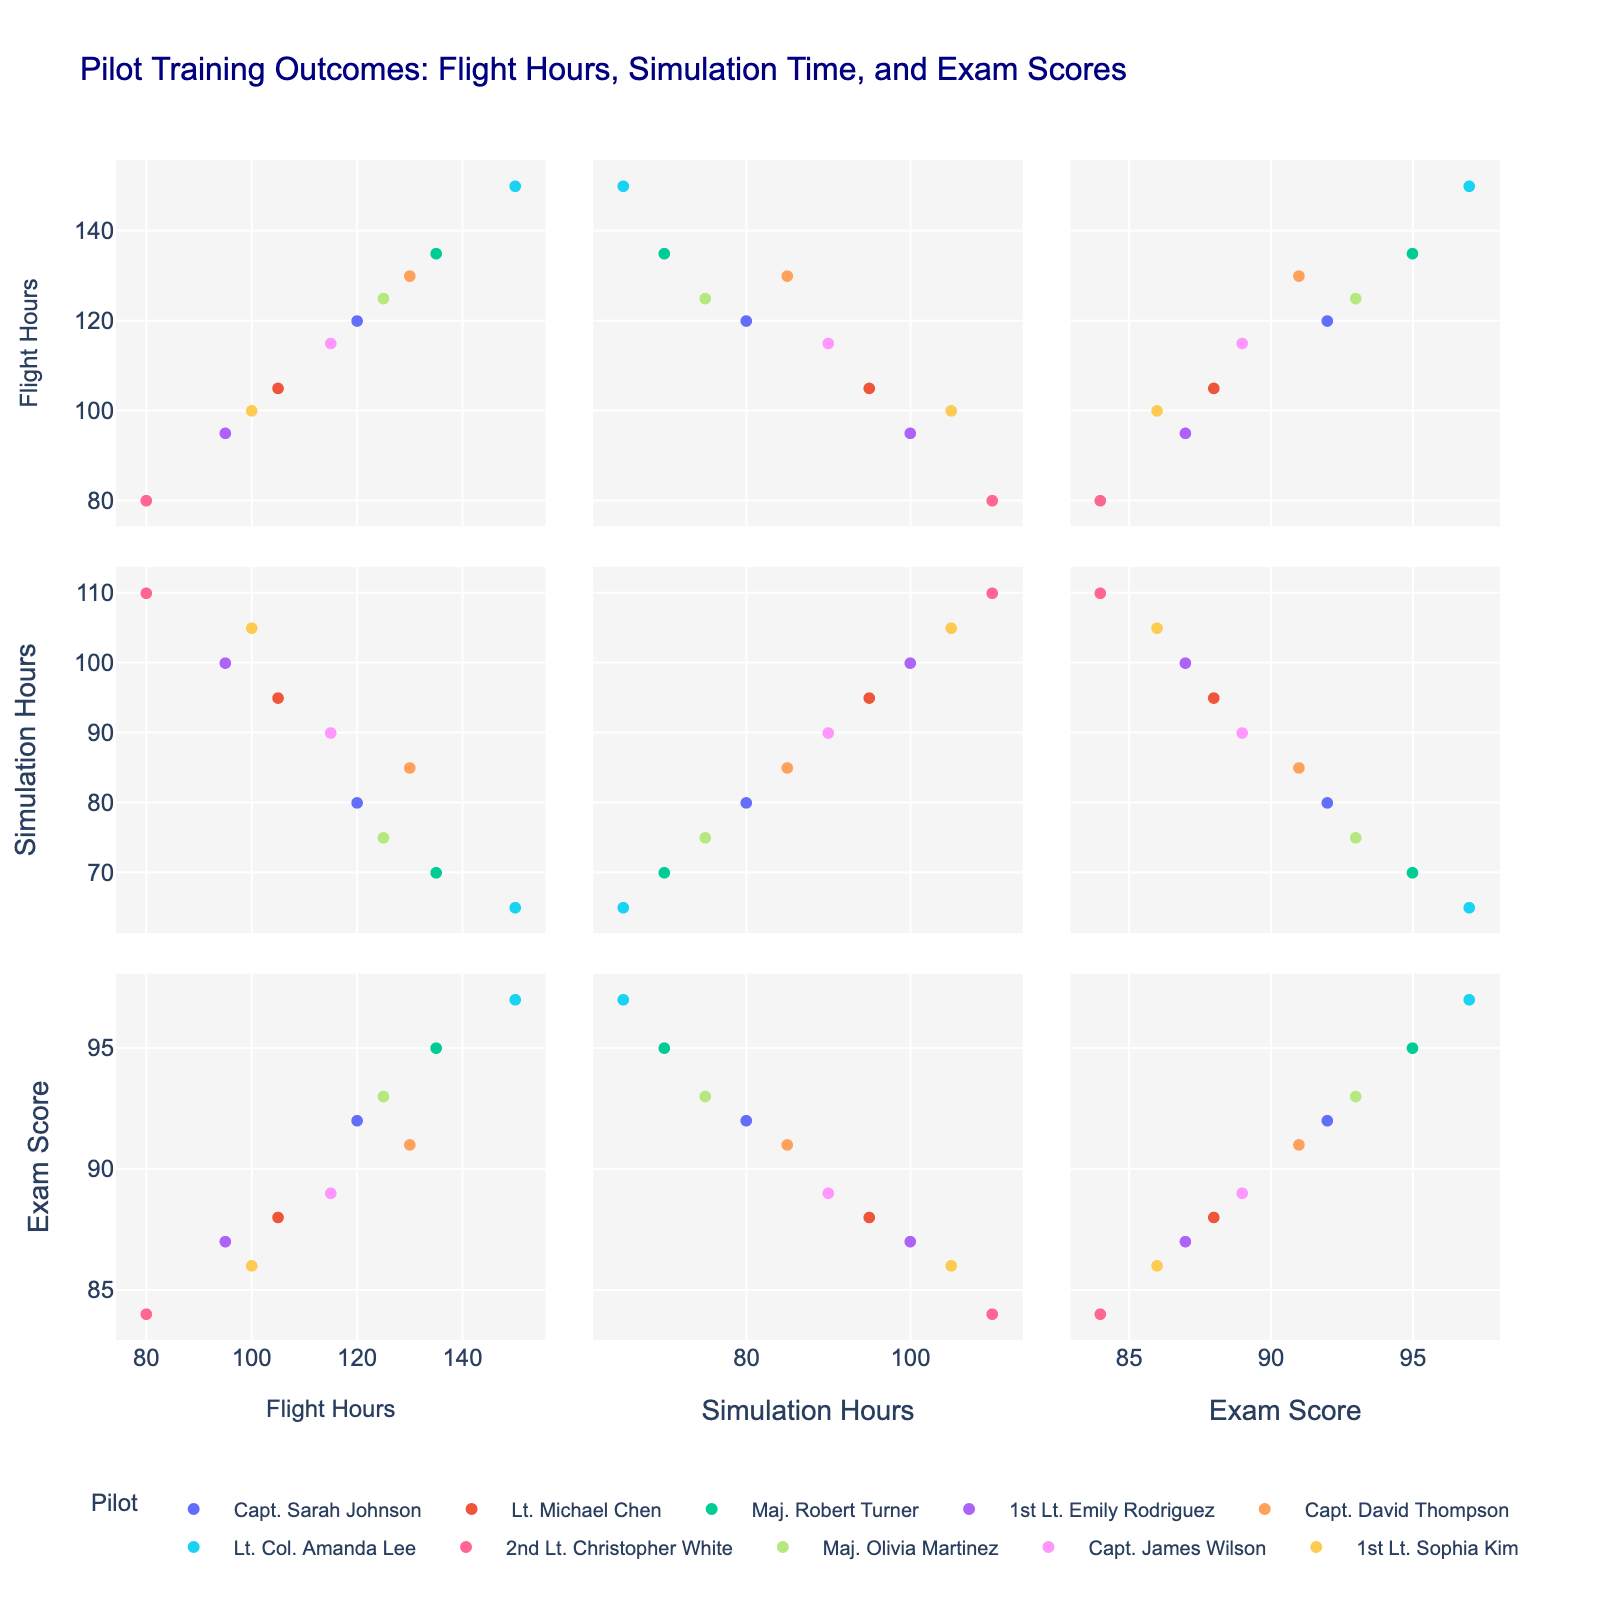What is the title of the scatterplot matrix? The title can be found at the top of the figure, typically in a larger and bolder font.
Answer: Pilot Training Outcomes: Flight Hours, Simulation Time, and Exam Scores How many pilots are plotted in the matrix? Count the number of unique colors or unique points listed in the legend as pilots.
Answer: 10 Which pilot has the lowest number of Flight Hours? Look for the lowest value on the x-axis of the 'Flight Hours' dimension and identify the corresponding pilot.
Answer: 2nd Lt. Christopher White What are the axes of the scatterplot matrix? Examine the axes labels in the matrix, which appear along the rows and columns in the scatterplot.
Answer: Flight Hours, Simulation Hours, Exam Score Which pilot has the highest Exam Score? Identify the highest value on the 'Exam Score' axis and match it with the corresponding pilot.
Answer: Lt. Col. Amanda Lee Which two pilots have the most similar Simulation Hours? Compare points along the 'Simulation Hours' axis and find the closest pair.
Answer: 1st Lt. Emily Rodriguez and 1st Lt. Sophia Kim Which dimension shows the widest range of values? Compare the range of values along each axis ('Flight Hours', 'Simulation Hours', 'Exam Score') in the scatterplot matrix.
Answer: Flight Hours How does exam performance generally relate to Flight Hours? Observe the scatter plots involving 'Exam Score' and 'Flight Hours' and describe the overall trend or pattern.
Answer: Generally positive correlation Which pilot spent max Simulation Hours but has a lower Exam Score than some others? Locate the pilot with the highest value on the 'Simulation Hours' axis and check their 'Exam Score' relative to others.
Answer: 2nd Lt. Christopher White Do pilots with above 100 Flight Hours generally score above 90 on the exam? Examine the 'Exam Score' for pilots with 'Flight Hours' greater than 100 and see if those scores are above 90.
Answer: Not generally 